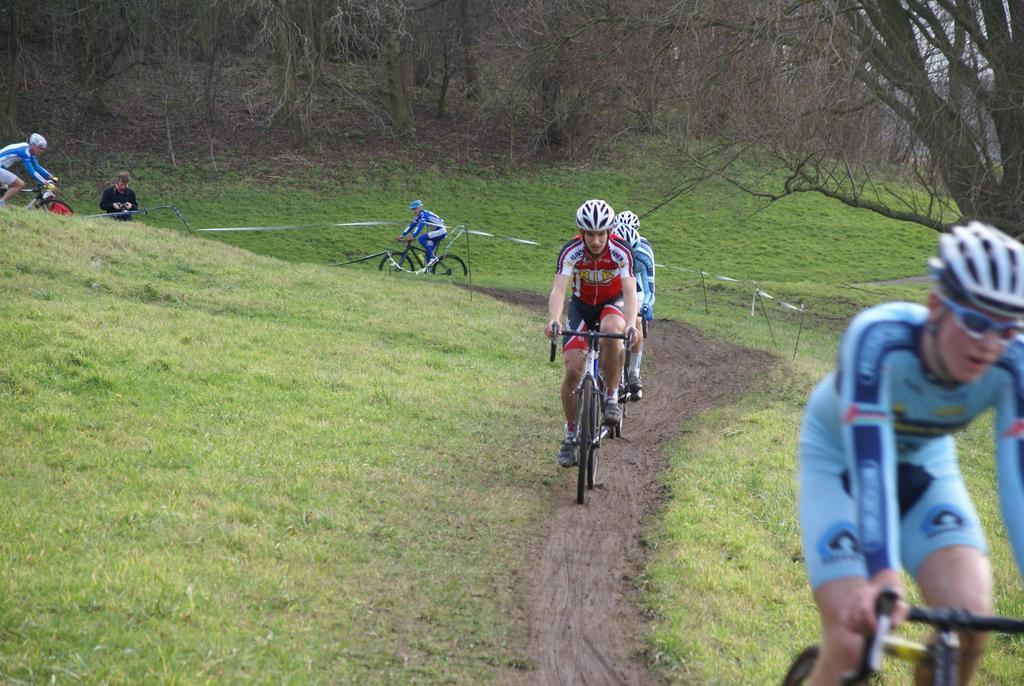How many people are in the image? There are many people in the image. What are the people wearing on their heads? The people are wearing helmets. Are there any people wearing additional protective gear? Yes, one person is wearing goggles. What are the people doing in the image? The people are riding cycles. What type of terrain can be seen in the image? There is grass on the ground. What is visible in the background of the image? There are trees in the background. What type of fowl can be seen flying in the image? There is no fowl visible in the image; the people are riding cycles and there are no birds mentioned in the facts. What color is the thread used to sew the mark on the person's helmet? There is no mention of a mark or thread in the image or the provided facts. 